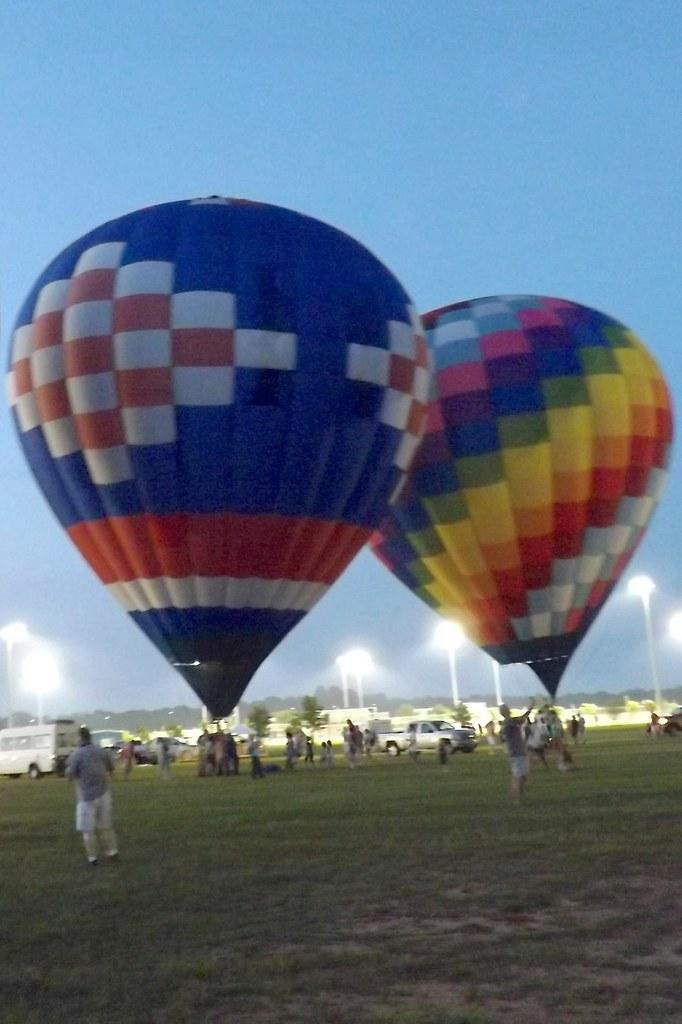What is the main subject of the image? The main subject of the image is hot air balloons. Can you describe the people in the image? There are people in the image, but their specific actions or appearances are not mentioned in the facts. What other objects or vehicles are present in the image? Cars are present in the image. Where are the hot air balloons, people, and cars located? They are located on grassland. What type of connection is being used by the hot air balloons in the image? There is no mention of a connection in the image, as hot air balloons are not typically associated with connections. --- Facts: 1. There is a person holding a book in the image. 2. The book has a red cover. 3. The person is sitting on a chair. 4. There is a table next to the chair. 5. The table has a lamp on it. Absurd Topics: dance, ocean, volcano Conversation: What is the person in the image holding? The person in the image is holding a book. Can you describe the book? The book has a red cover. Where is the person sitting? The person is sitting on a chair. What is next to the chair? There is a table next to the chair. What is on the table? The table has a lamp on it. Reasoning: Let's think step by step in order to produce the conversation. We start by identifying the main subject of the image, which is the person holding a book. Then, we describe the book's appearance, mentioning its red cover. Next, we describe the person's location, noting that they are sitting on a chair. Finally, we mention the presence of a table next to the chair and describe an object on the table, which is a lamp. Absurd Question/Answer: Can you see any volcanoes in the image? No, there are no volcanoes present in the image. 